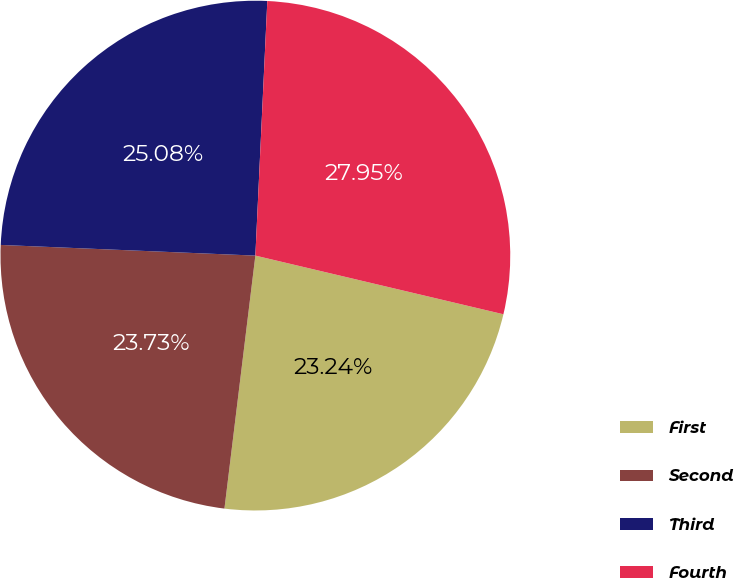<chart> <loc_0><loc_0><loc_500><loc_500><pie_chart><fcel>First<fcel>Second<fcel>Third<fcel>Fourth<nl><fcel>23.24%<fcel>23.73%<fcel>25.08%<fcel>27.95%<nl></chart> 